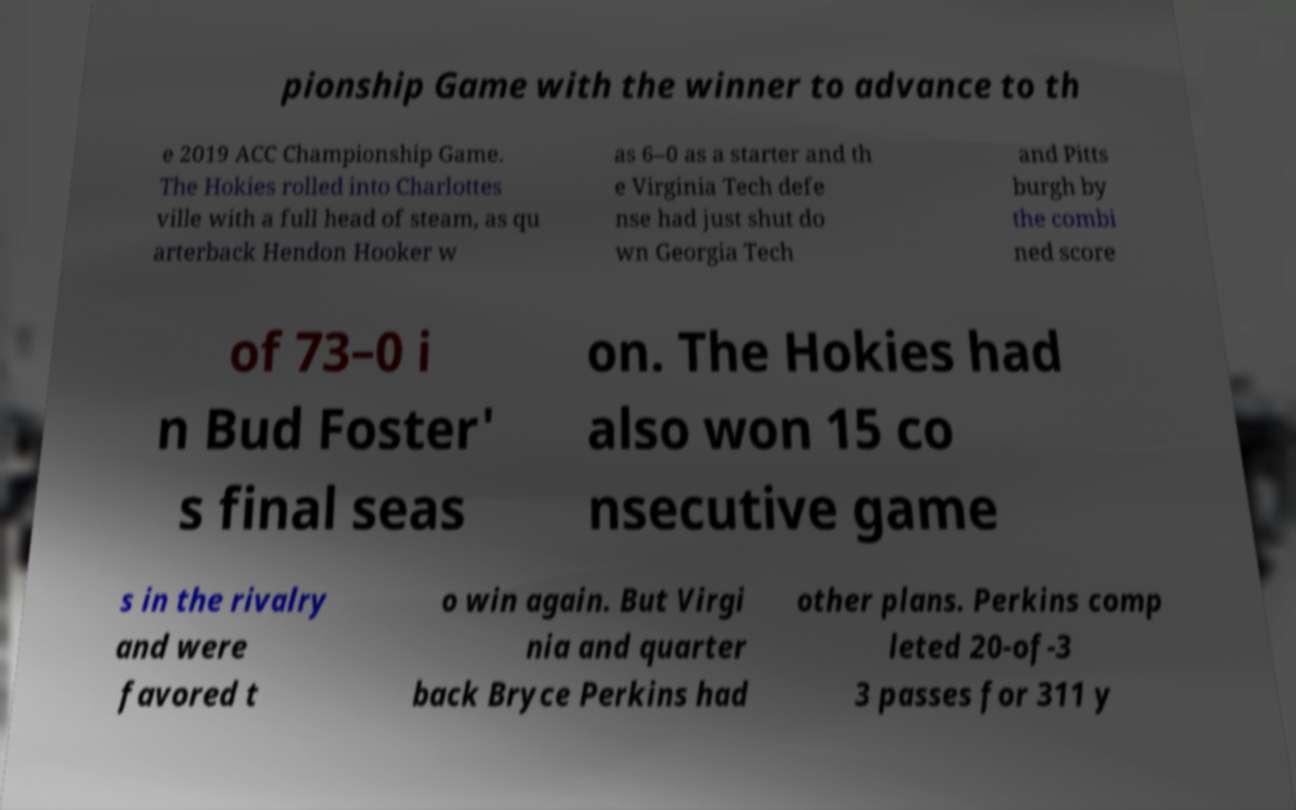What messages or text are displayed in this image? I need them in a readable, typed format. pionship Game with the winner to advance to th e 2019 ACC Championship Game. The Hokies rolled into Charlottes ville with a full head of steam, as qu arterback Hendon Hooker w as 6–0 as a starter and th e Virginia Tech defe nse had just shut do wn Georgia Tech and Pitts burgh by the combi ned score of 73–0 i n Bud Foster' s final seas on. The Hokies had also won 15 co nsecutive game s in the rivalry and were favored t o win again. But Virgi nia and quarter back Bryce Perkins had other plans. Perkins comp leted 20-of-3 3 passes for 311 y 